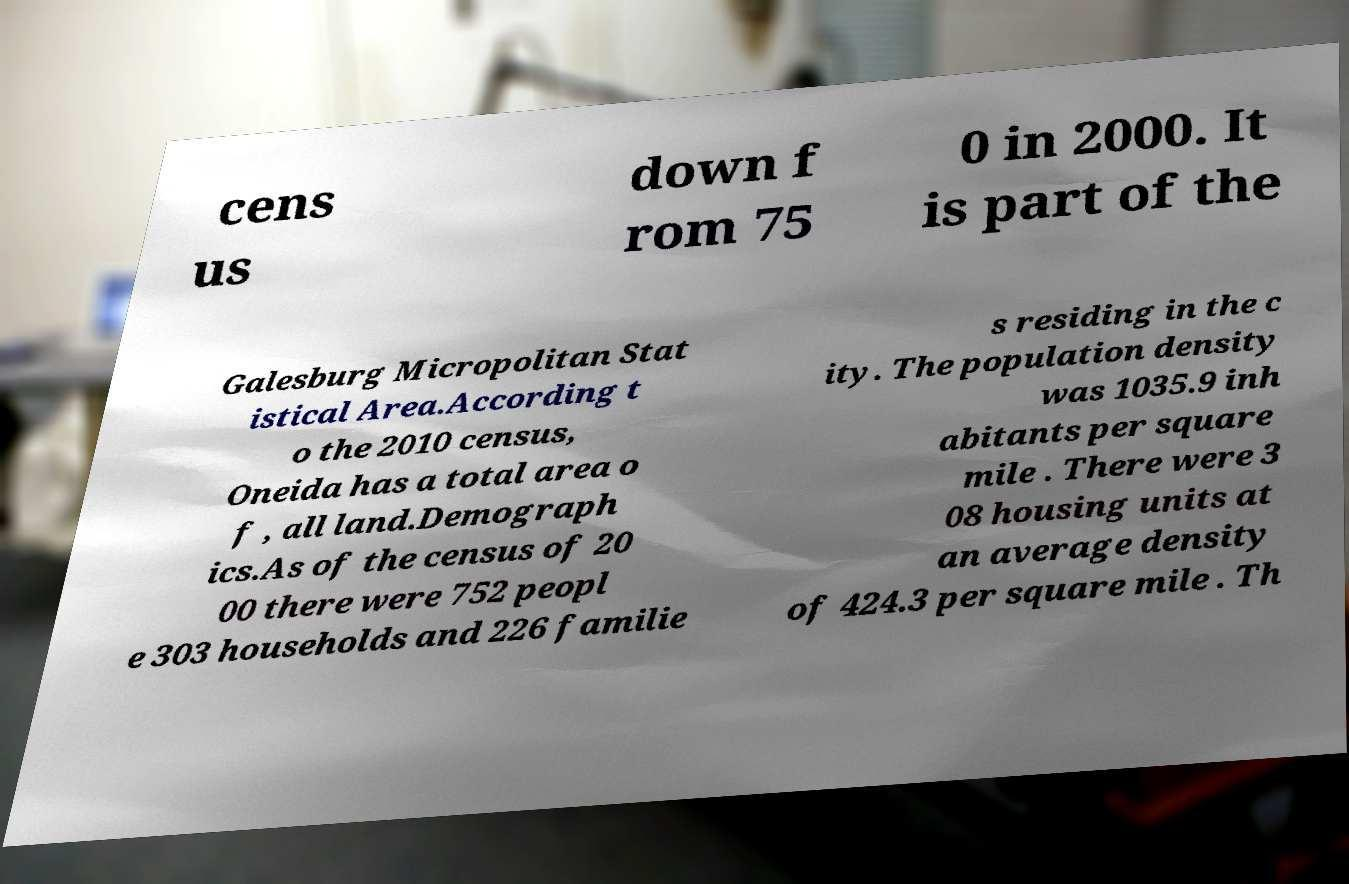Please identify and transcribe the text found in this image. cens us down f rom 75 0 in 2000. It is part of the Galesburg Micropolitan Stat istical Area.According t o the 2010 census, Oneida has a total area o f , all land.Demograph ics.As of the census of 20 00 there were 752 peopl e 303 households and 226 familie s residing in the c ity. The population density was 1035.9 inh abitants per square mile . There were 3 08 housing units at an average density of 424.3 per square mile . Th 